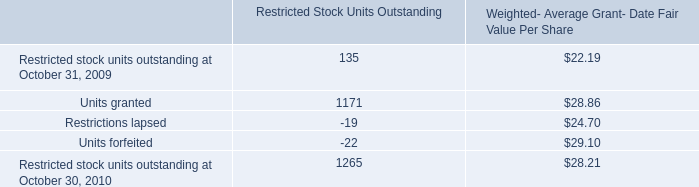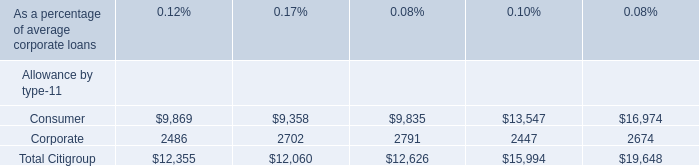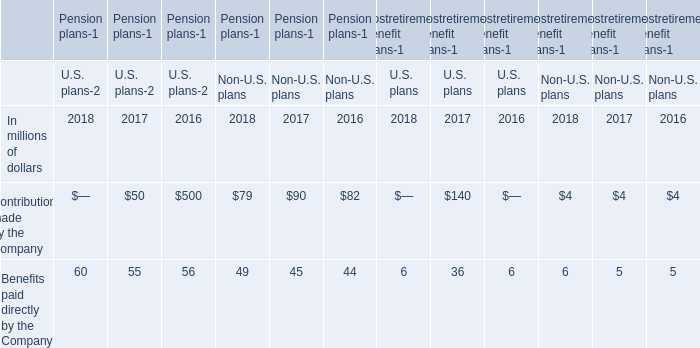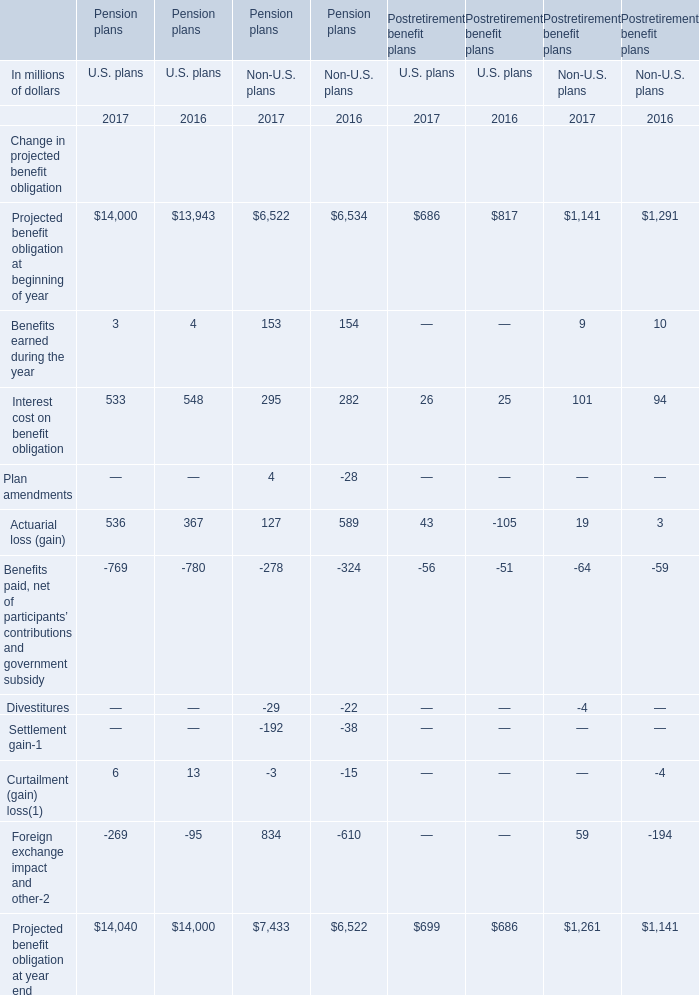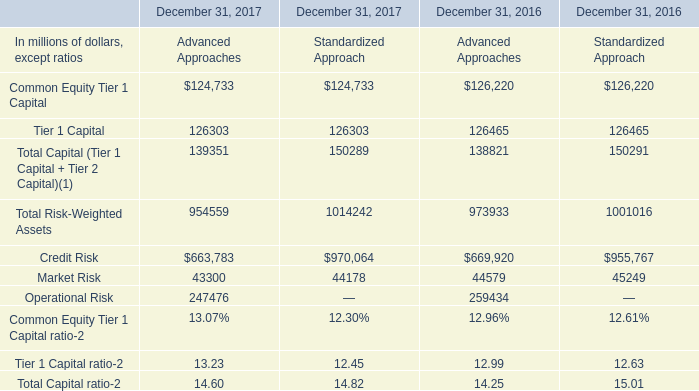What's the growth rate of Benefits paid directly by the Company in 2017 for U.S. plans? 
Computations: ((60 - 55) / 55)
Answer: 0.09091. 